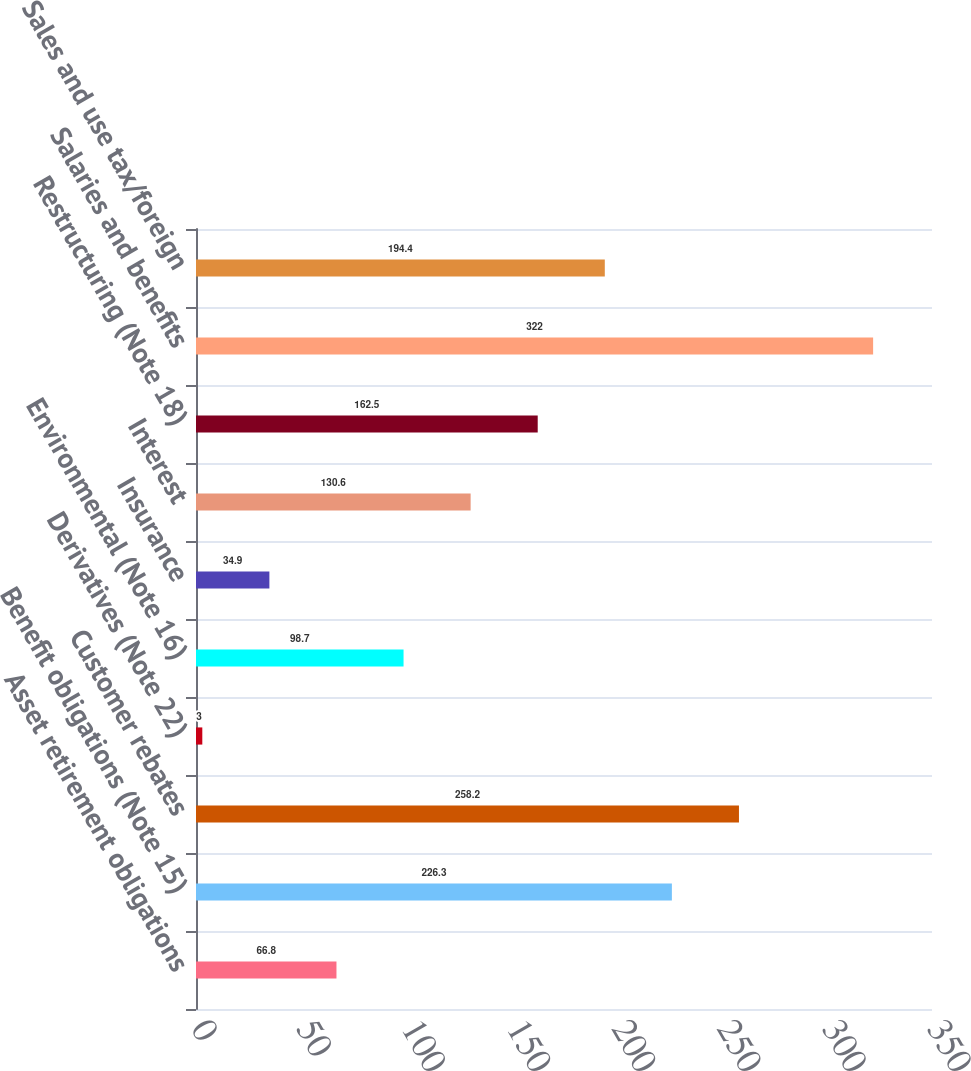Convert chart to OTSL. <chart><loc_0><loc_0><loc_500><loc_500><bar_chart><fcel>Asset retirement obligations<fcel>Benefit obligations (Note 15)<fcel>Customer rebates<fcel>Derivatives (Note 22)<fcel>Environmental (Note 16)<fcel>Insurance<fcel>Interest<fcel>Restructuring (Note 18)<fcel>Salaries and benefits<fcel>Sales and use tax/foreign<nl><fcel>66.8<fcel>226.3<fcel>258.2<fcel>3<fcel>98.7<fcel>34.9<fcel>130.6<fcel>162.5<fcel>322<fcel>194.4<nl></chart> 